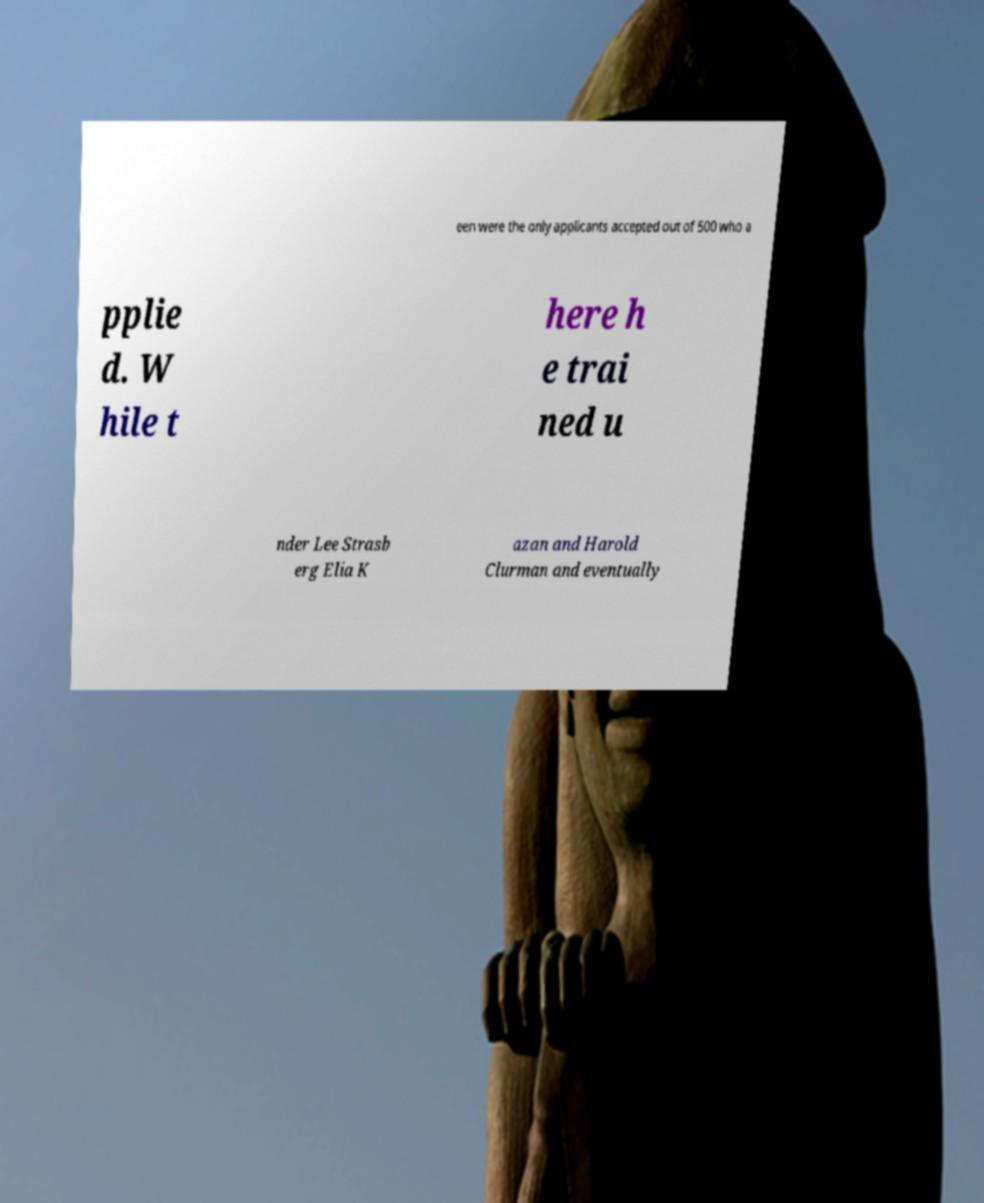Please read and relay the text visible in this image. What does it say? een were the only applicants accepted out of 500 who a pplie d. W hile t here h e trai ned u nder Lee Strasb erg Elia K azan and Harold Clurman and eventually 